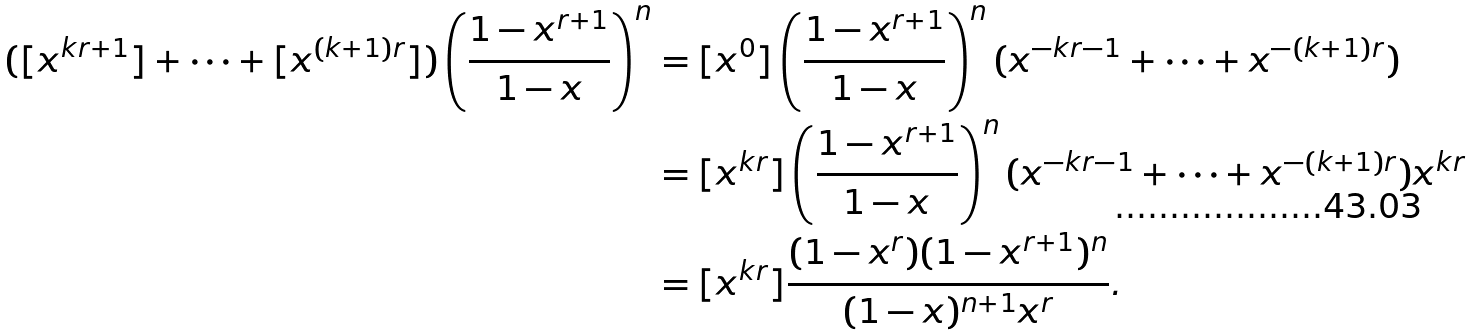Convert formula to latex. <formula><loc_0><loc_0><loc_500><loc_500>( [ x ^ { k r + 1 } ] + \cdots + [ x ^ { ( k + 1 ) r } ] ) \left ( \frac { 1 - x ^ { r + 1 } } { 1 - x } \right ) ^ { n } & = [ x ^ { 0 } ] \left ( \frac { 1 - x ^ { r + 1 } } { 1 - x } \right ) ^ { n } ( x ^ { - k r - 1 } + \cdots + x ^ { - ( k + 1 ) r } ) \\ & = [ x ^ { k r } ] \left ( \frac { 1 - x ^ { r + 1 } } { 1 - x } \right ) ^ { n } ( x ^ { - k r - 1 } + \cdots + x ^ { - ( k + 1 ) r } ) x ^ { k r } \\ & = [ x ^ { k r } ] \frac { ( 1 - x ^ { r } ) ( 1 - x ^ { r + 1 } ) ^ { n } } { ( 1 - x ) ^ { n + 1 } x ^ { r } } .</formula> 